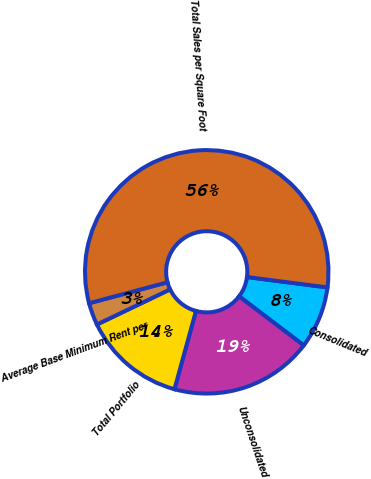<chart> <loc_0><loc_0><loc_500><loc_500><pie_chart><fcel>Consolidated<fcel>Unconsolidated<fcel>Total Portfolio<fcel>Average Base Minimum Rent per<fcel>Total Sales per Square Foot<nl><fcel>8.29%<fcel>18.94%<fcel>13.61%<fcel>2.97%<fcel>56.2%<nl></chart> 